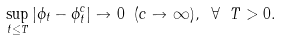<formula> <loc_0><loc_0><loc_500><loc_500>\sup _ { t \leq T } | \phi _ { t } - \phi ^ { c } _ { t } | \to 0 \ ( c \to \infty ) , \ \forall \ T > 0 .</formula> 